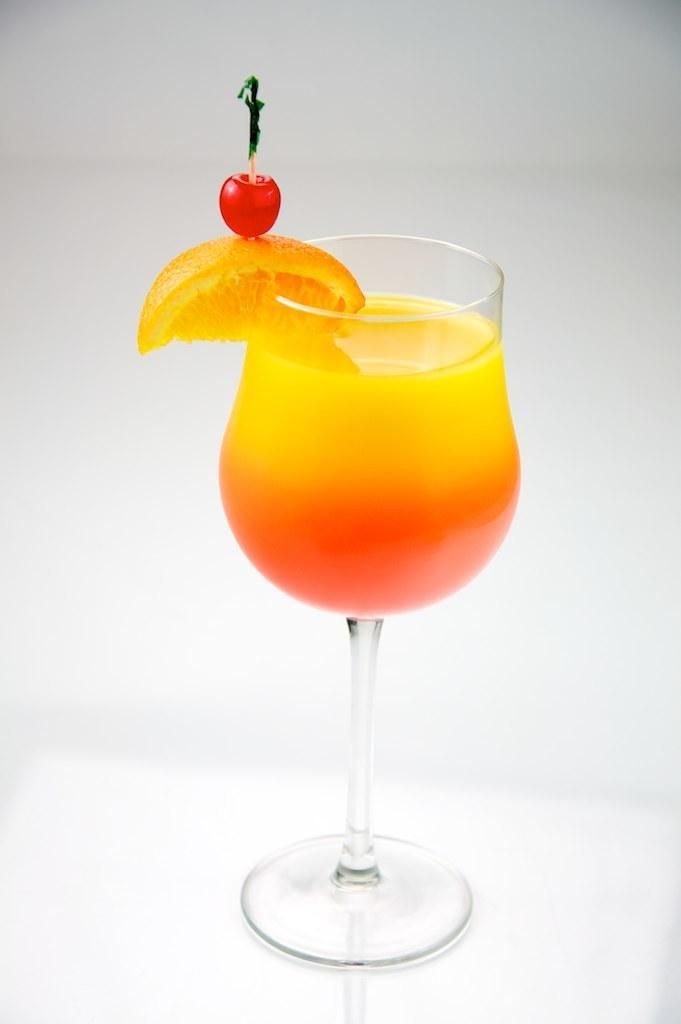What is in the glass that is visible in the image? The glass contains a yellow and orange drink. Are there any additional items on or near the glass? Yes, there is a piece of lemon and a cherry on the glass. What is the color of the background in the image? The background of the image is white. What type of agreement is being discussed in the image? There is no discussion or agreement present in the image; it features a glass with a yellow and orange drink, a piece of lemon, and a cherry. Can you see any curtains in the image? There are no curtains visible in the image. 